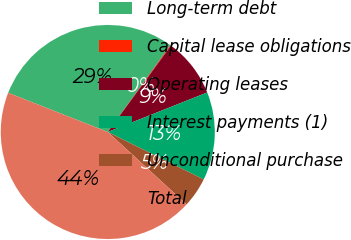Convert chart. <chart><loc_0><loc_0><loc_500><loc_500><pie_chart><fcel>Long-term debt<fcel>Capital lease obligations<fcel>Operating leases<fcel>Interest payments (1)<fcel>Unconditional purchase<fcel>Total<nl><fcel>28.97%<fcel>0.12%<fcel>8.92%<fcel>13.33%<fcel>4.52%<fcel>44.13%<nl></chart> 